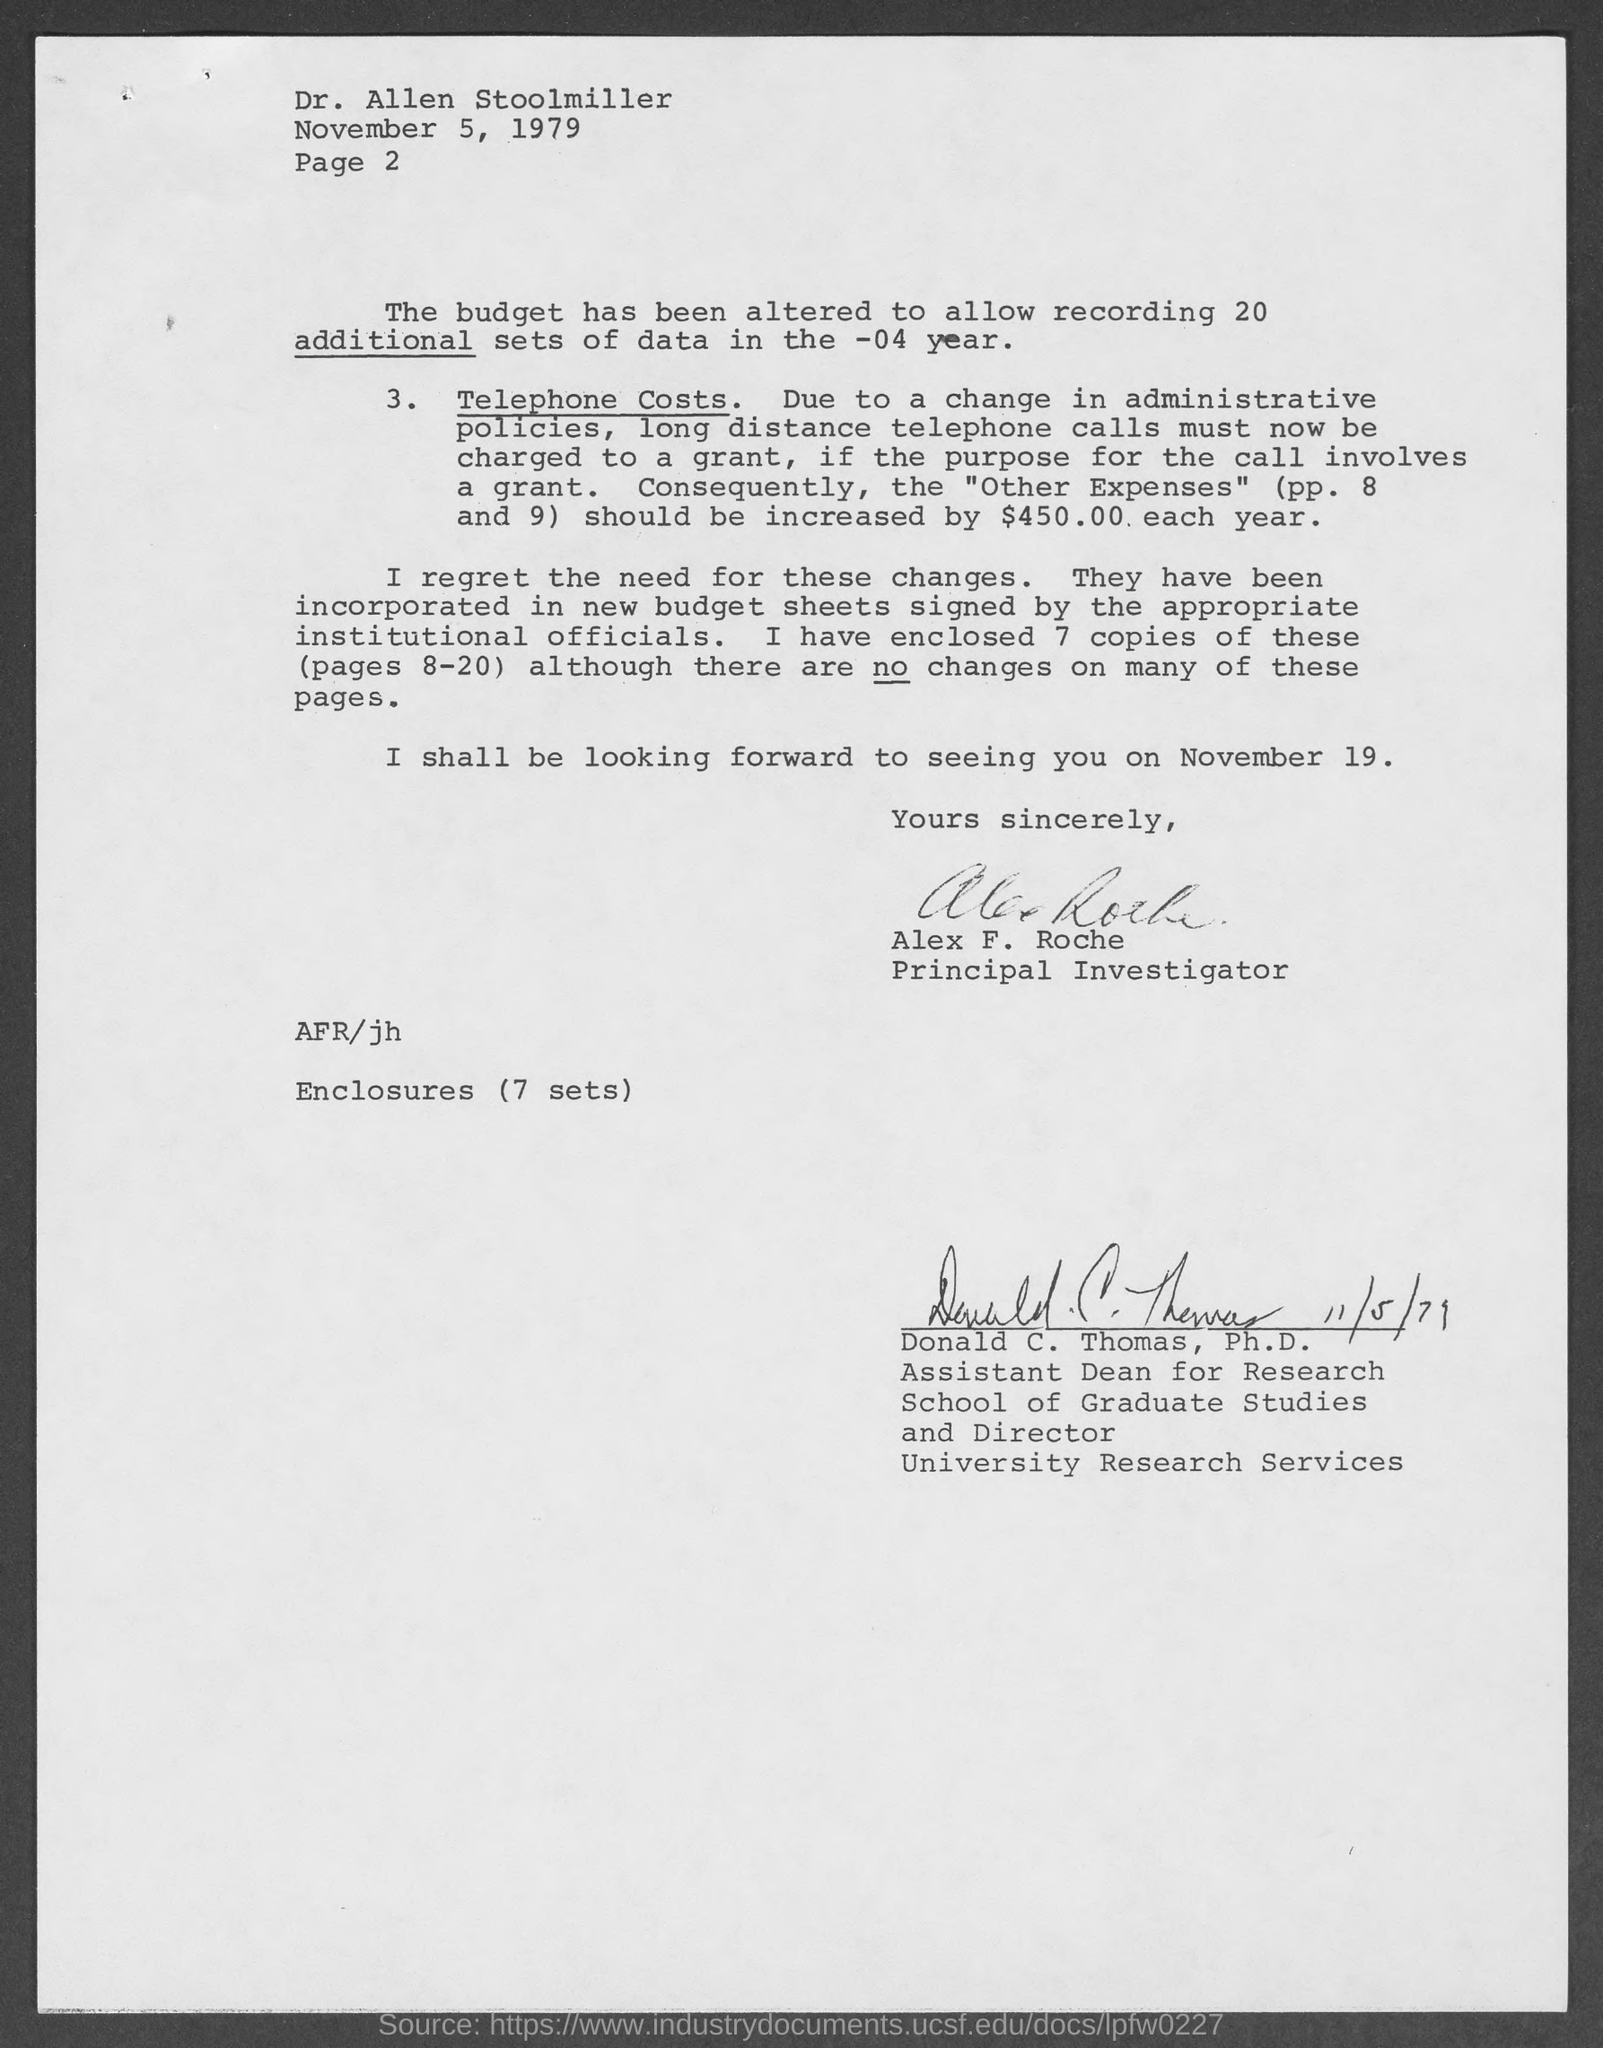What is the date on the document?
Give a very brief answer. November 5, 1979. To Whom is this letter addressed to?
Provide a succinct answer. Dr. Allen Stoolmiller. Who is this letter from?
Keep it short and to the point. Alex F. Roche. When is he going to meet?
Provide a short and direct response. November 19. 